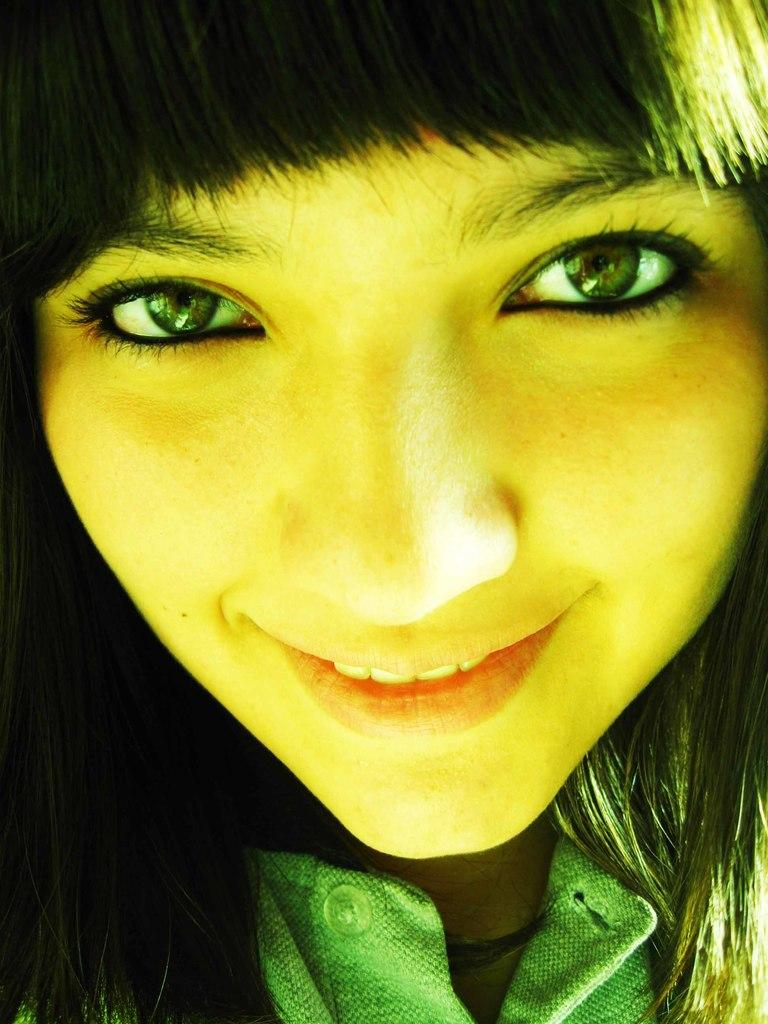What is the main subject of the image? The main subject of the image is a lady. What is the lady wearing in the image? The lady is wearing a green dress in the image. What is the lady's facial expression in the image? The lady is smiling in the image. What type of rabbit can be seen in the lady's hand in the image? There is no rabbit present in the image. 